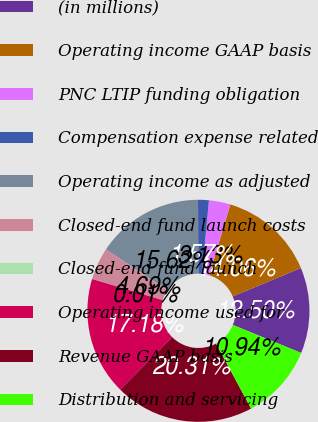Convert chart. <chart><loc_0><loc_0><loc_500><loc_500><pie_chart><fcel>(in millions)<fcel>Operating income GAAP basis<fcel>PNC LTIP funding obligation<fcel>Compensation expense related<fcel>Operating income as adjusted<fcel>Closed-end fund launch costs<fcel>Closed-end fund launch<fcel>Operating income used for<fcel>Revenue GAAP basis<fcel>Distribution and servicing<nl><fcel>12.5%<fcel>14.06%<fcel>3.13%<fcel>1.57%<fcel>15.62%<fcel>4.69%<fcel>0.01%<fcel>17.18%<fcel>20.31%<fcel>10.94%<nl></chart> 